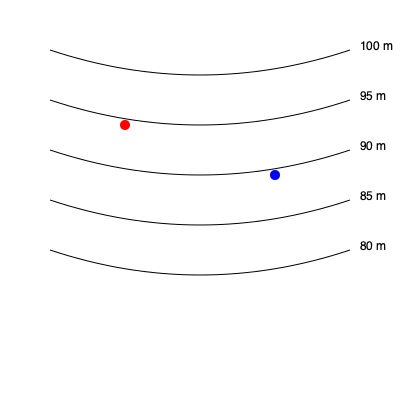Given the topographic map above with contour lines at 5-meter intervals, what is the approximate elevation difference between the red and blue points? To determine the elevation difference between the red and blue points, we need to follow these steps:

1. Identify the elevation of the red point:
   - The red point is located between the 95 m and 90 m contour lines
   - It appears to be closer to the 95 m line
   - We can estimate its elevation as approximately 93 m

2. Identify the elevation of the blue point:
   - The blue point is located between the 90 m and 85 m contour lines
   - It appears to be closer to the 85 m line
   - We can estimate its elevation as approximately 87 m

3. Calculate the elevation difference:
   $\text{Elevation difference} = \text{Red point elevation} - \text{Blue point elevation}$
   $\text{Elevation difference} = 93 \text{ m} - 87 \text{ m} = 6 \text{ m}$

Therefore, the approximate elevation difference between the red and blue points is 6 meters.
Answer: 6 meters 